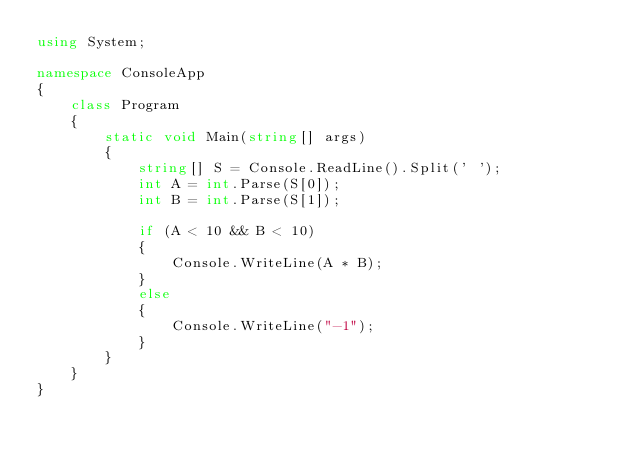<code> <loc_0><loc_0><loc_500><loc_500><_C#_>using System;

namespace ConsoleApp
{
    class Program
    {
        static void Main(string[] args)
        {
            string[] S = Console.ReadLine().Split(' ');
            int A = int.Parse(S[0]);
            int B = int.Parse(S[1]);

            if (A < 10 && B < 10)
            {
                Console.WriteLine(A * B);
            }
            else
            {
                Console.WriteLine("-1");
            }
        }
    }
}</code> 